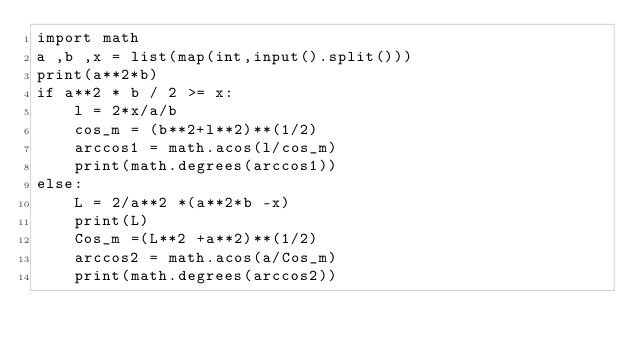<code> <loc_0><loc_0><loc_500><loc_500><_Python_>import math
a ,b ,x = list(map(int,input().split()))
print(a**2*b)
if a**2 * b / 2 >= x:
    l = 2*x/a/b
    cos_m = (b**2+l**2)**(1/2)
    arccos1 = math.acos(l/cos_m)
    print(math.degrees(arccos1))
else:
    L = 2/a**2 *(a**2*b -x)
    print(L)
    Cos_m =(L**2 +a**2)**(1/2)
    arccos2 = math.acos(a/Cos_m)
    print(math.degrees(arccos2))
</code> 